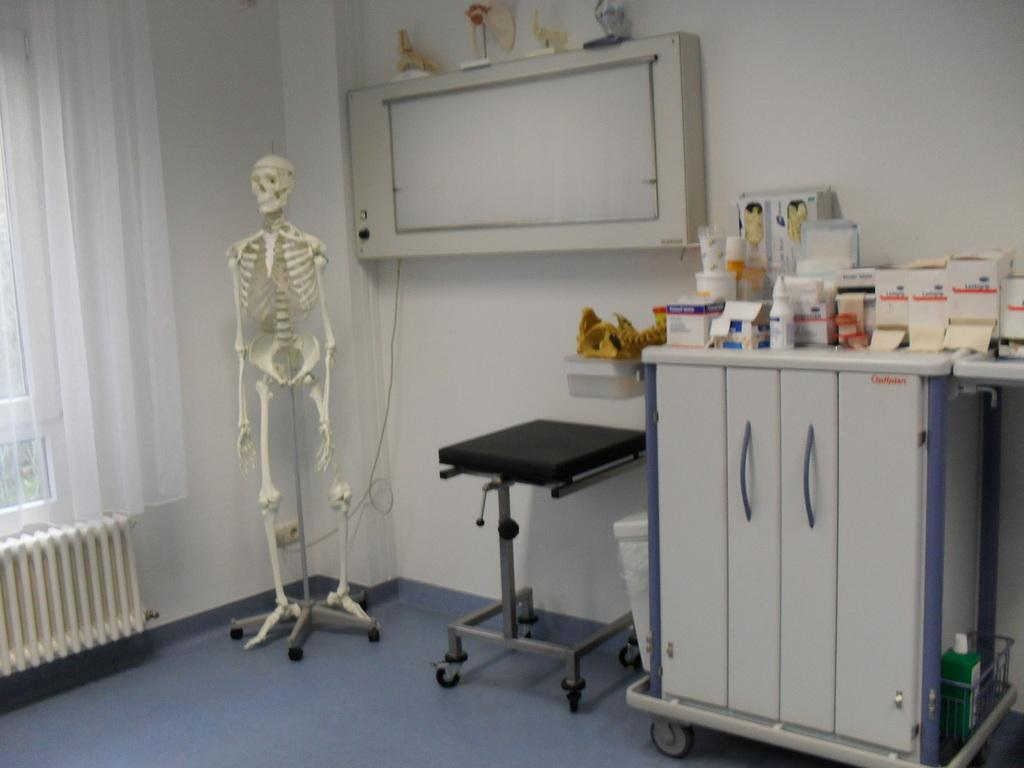What is the main subject of the image? There is a skeleton on a stand in the image. What can be seen in the background of the image? There is a curtain on a window in the image. What items are on the table in the image? There are medicines on a table in the image. Where is the cannon located in the image? There is no cannon present in the image. What type of stone is used to build the shelf in the image? There is no shelf present in the image. 